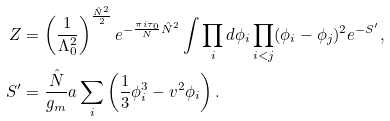Convert formula to latex. <formula><loc_0><loc_0><loc_500><loc_500>Z & = \left ( \frac { 1 } { \Lambda _ { 0 } ^ { 2 } } \right ) ^ { \frac { \hat { N } ^ { 2 } } 2 } e ^ { - \frac { \pi i \tau _ { 0 } } { N } \hat { N } ^ { 2 } } \int \prod _ { i } d \phi _ { i } \prod _ { i < j } ( \phi _ { i } - \phi _ { j } ) ^ { 2 } e ^ { - S ^ { \prime } } , \\ S ^ { \prime } & = \frac { \hat { N } } { g _ { m } } a \sum _ { i } \left ( \frac { 1 } { 3 } \phi _ { i } ^ { 3 } - v ^ { 2 } \phi _ { i } \right ) .</formula> 